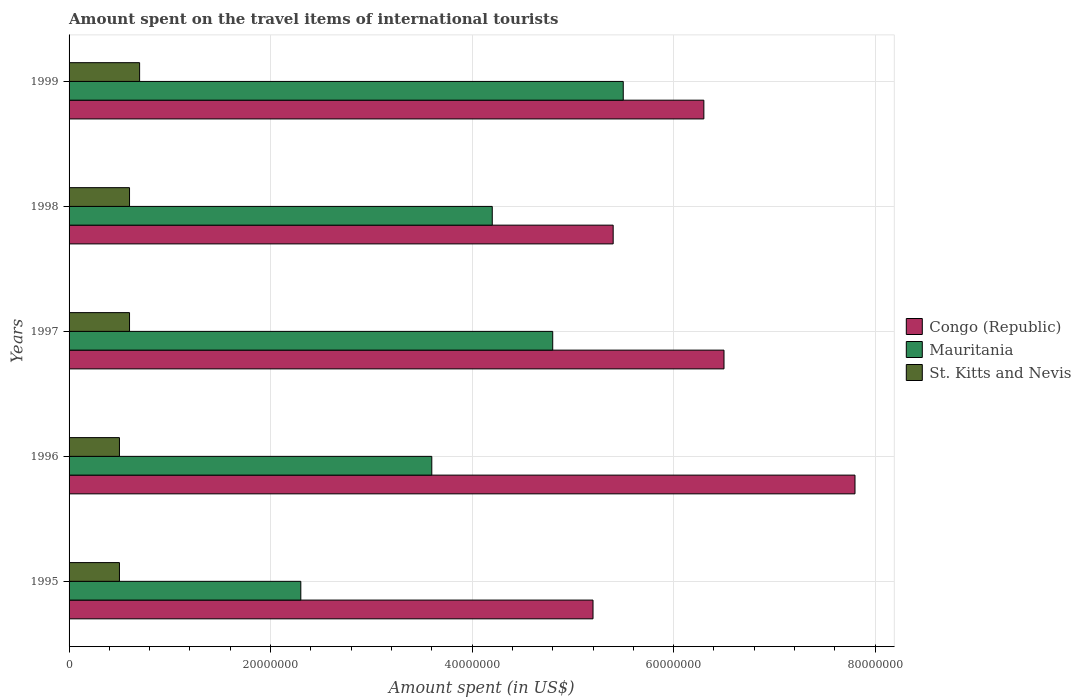How many different coloured bars are there?
Offer a terse response. 3. Are the number of bars on each tick of the Y-axis equal?
Your response must be concise. Yes. How many bars are there on the 4th tick from the bottom?
Provide a succinct answer. 3. In how many cases, is the number of bars for a given year not equal to the number of legend labels?
Make the answer very short. 0. What is the amount spent on the travel items of international tourists in St. Kitts and Nevis in 1997?
Provide a short and direct response. 6.00e+06. Across all years, what is the maximum amount spent on the travel items of international tourists in Congo (Republic)?
Your response must be concise. 7.80e+07. Across all years, what is the minimum amount spent on the travel items of international tourists in Mauritania?
Offer a very short reply. 2.30e+07. What is the total amount spent on the travel items of international tourists in Mauritania in the graph?
Your answer should be compact. 2.04e+08. What is the difference between the amount spent on the travel items of international tourists in St. Kitts and Nevis in 1998 and that in 1999?
Make the answer very short. -1.00e+06. What is the difference between the amount spent on the travel items of international tourists in Mauritania in 1996 and the amount spent on the travel items of international tourists in Congo (Republic) in 1997?
Offer a terse response. -2.90e+07. What is the average amount spent on the travel items of international tourists in Congo (Republic) per year?
Provide a short and direct response. 6.24e+07. In how many years, is the amount spent on the travel items of international tourists in Congo (Republic) greater than 64000000 US$?
Offer a terse response. 2. What is the ratio of the amount spent on the travel items of international tourists in Mauritania in 1997 to that in 1998?
Offer a terse response. 1.14. Is the amount spent on the travel items of international tourists in St. Kitts and Nevis in 1995 less than that in 1996?
Your response must be concise. No. Is the difference between the amount spent on the travel items of international tourists in Congo (Republic) in 1995 and 1998 greater than the difference between the amount spent on the travel items of international tourists in Mauritania in 1995 and 1998?
Your answer should be compact. Yes. What is the difference between the highest and the second highest amount spent on the travel items of international tourists in Mauritania?
Keep it short and to the point. 7.00e+06. What is the difference between the highest and the lowest amount spent on the travel items of international tourists in Mauritania?
Your answer should be very brief. 3.20e+07. In how many years, is the amount spent on the travel items of international tourists in St. Kitts and Nevis greater than the average amount spent on the travel items of international tourists in St. Kitts and Nevis taken over all years?
Make the answer very short. 3. What does the 2nd bar from the top in 1995 represents?
Provide a succinct answer. Mauritania. What does the 2nd bar from the bottom in 1996 represents?
Offer a terse response. Mauritania. How many bars are there?
Provide a succinct answer. 15. How many years are there in the graph?
Your answer should be compact. 5. Are the values on the major ticks of X-axis written in scientific E-notation?
Your answer should be very brief. No. Does the graph contain any zero values?
Provide a succinct answer. No. Where does the legend appear in the graph?
Provide a short and direct response. Center right. How many legend labels are there?
Keep it short and to the point. 3. How are the legend labels stacked?
Offer a very short reply. Vertical. What is the title of the graph?
Offer a terse response. Amount spent on the travel items of international tourists. What is the label or title of the X-axis?
Ensure brevity in your answer.  Amount spent (in US$). What is the label or title of the Y-axis?
Your answer should be compact. Years. What is the Amount spent (in US$) in Congo (Republic) in 1995?
Your answer should be very brief. 5.20e+07. What is the Amount spent (in US$) in Mauritania in 1995?
Give a very brief answer. 2.30e+07. What is the Amount spent (in US$) in St. Kitts and Nevis in 1995?
Your response must be concise. 5.00e+06. What is the Amount spent (in US$) in Congo (Republic) in 1996?
Provide a short and direct response. 7.80e+07. What is the Amount spent (in US$) in Mauritania in 1996?
Your response must be concise. 3.60e+07. What is the Amount spent (in US$) in St. Kitts and Nevis in 1996?
Ensure brevity in your answer.  5.00e+06. What is the Amount spent (in US$) of Congo (Republic) in 1997?
Your answer should be very brief. 6.50e+07. What is the Amount spent (in US$) of Mauritania in 1997?
Ensure brevity in your answer.  4.80e+07. What is the Amount spent (in US$) in Congo (Republic) in 1998?
Make the answer very short. 5.40e+07. What is the Amount spent (in US$) of Mauritania in 1998?
Give a very brief answer. 4.20e+07. What is the Amount spent (in US$) of Congo (Republic) in 1999?
Your answer should be very brief. 6.30e+07. What is the Amount spent (in US$) in Mauritania in 1999?
Your answer should be compact. 5.50e+07. What is the Amount spent (in US$) in St. Kitts and Nevis in 1999?
Provide a short and direct response. 7.00e+06. Across all years, what is the maximum Amount spent (in US$) in Congo (Republic)?
Offer a terse response. 7.80e+07. Across all years, what is the maximum Amount spent (in US$) in Mauritania?
Offer a very short reply. 5.50e+07. Across all years, what is the minimum Amount spent (in US$) in Congo (Republic)?
Provide a succinct answer. 5.20e+07. Across all years, what is the minimum Amount spent (in US$) of Mauritania?
Your response must be concise. 2.30e+07. Across all years, what is the minimum Amount spent (in US$) of St. Kitts and Nevis?
Give a very brief answer. 5.00e+06. What is the total Amount spent (in US$) of Congo (Republic) in the graph?
Provide a short and direct response. 3.12e+08. What is the total Amount spent (in US$) of Mauritania in the graph?
Keep it short and to the point. 2.04e+08. What is the total Amount spent (in US$) in St. Kitts and Nevis in the graph?
Ensure brevity in your answer.  2.90e+07. What is the difference between the Amount spent (in US$) in Congo (Republic) in 1995 and that in 1996?
Ensure brevity in your answer.  -2.60e+07. What is the difference between the Amount spent (in US$) in Mauritania in 1995 and that in 1996?
Give a very brief answer. -1.30e+07. What is the difference between the Amount spent (in US$) in Congo (Republic) in 1995 and that in 1997?
Your answer should be very brief. -1.30e+07. What is the difference between the Amount spent (in US$) of Mauritania in 1995 and that in 1997?
Your answer should be compact. -2.50e+07. What is the difference between the Amount spent (in US$) of Mauritania in 1995 and that in 1998?
Your answer should be very brief. -1.90e+07. What is the difference between the Amount spent (in US$) in Congo (Republic) in 1995 and that in 1999?
Give a very brief answer. -1.10e+07. What is the difference between the Amount spent (in US$) of Mauritania in 1995 and that in 1999?
Provide a succinct answer. -3.20e+07. What is the difference between the Amount spent (in US$) in St. Kitts and Nevis in 1995 and that in 1999?
Ensure brevity in your answer.  -2.00e+06. What is the difference between the Amount spent (in US$) of Congo (Republic) in 1996 and that in 1997?
Make the answer very short. 1.30e+07. What is the difference between the Amount spent (in US$) in Mauritania in 1996 and that in 1997?
Your answer should be very brief. -1.20e+07. What is the difference between the Amount spent (in US$) in St. Kitts and Nevis in 1996 and that in 1997?
Make the answer very short. -1.00e+06. What is the difference between the Amount spent (in US$) in Congo (Republic) in 1996 and that in 1998?
Give a very brief answer. 2.40e+07. What is the difference between the Amount spent (in US$) in Mauritania in 1996 and that in 1998?
Your answer should be very brief. -6.00e+06. What is the difference between the Amount spent (in US$) of St. Kitts and Nevis in 1996 and that in 1998?
Your answer should be very brief. -1.00e+06. What is the difference between the Amount spent (in US$) in Congo (Republic) in 1996 and that in 1999?
Your answer should be very brief. 1.50e+07. What is the difference between the Amount spent (in US$) of Mauritania in 1996 and that in 1999?
Your answer should be compact. -1.90e+07. What is the difference between the Amount spent (in US$) of Congo (Republic) in 1997 and that in 1998?
Your answer should be very brief. 1.10e+07. What is the difference between the Amount spent (in US$) in Mauritania in 1997 and that in 1999?
Your answer should be very brief. -7.00e+06. What is the difference between the Amount spent (in US$) in St. Kitts and Nevis in 1997 and that in 1999?
Your answer should be very brief. -1.00e+06. What is the difference between the Amount spent (in US$) in Congo (Republic) in 1998 and that in 1999?
Give a very brief answer. -9.00e+06. What is the difference between the Amount spent (in US$) in Mauritania in 1998 and that in 1999?
Ensure brevity in your answer.  -1.30e+07. What is the difference between the Amount spent (in US$) in Congo (Republic) in 1995 and the Amount spent (in US$) in Mauritania in 1996?
Your answer should be compact. 1.60e+07. What is the difference between the Amount spent (in US$) of Congo (Republic) in 1995 and the Amount spent (in US$) of St. Kitts and Nevis in 1996?
Provide a short and direct response. 4.70e+07. What is the difference between the Amount spent (in US$) in Mauritania in 1995 and the Amount spent (in US$) in St. Kitts and Nevis in 1996?
Your answer should be compact. 1.80e+07. What is the difference between the Amount spent (in US$) of Congo (Republic) in 1995 and the Amount spent (in US$) of St. Kitts and Nevis in 1997?
Give a very brief answer. 4.60e+07. What is the difference between the Amount spent (in US$) of Mauritania in 1995 and the Amount spent (in US$) of St. Kitts and Nevis in 1997?
Provide a succinct answer. 1.70e+07. What is the difference between the Amount spent (in US$) of Congo (Republic) in 1995 and the Amount spent (in US$) of St. Kitts and Nevis in 1998?
Make the answer very short. 4.60e+07. What is the difference between the Amount spent (in US$) in Mauritania in 1995 and the Amount spent (in US$) in St. Kitts and Nevis in 1998?
Offer a terse response. 1.70e+07. What is the difference between the Amount spent (in US$) in Congo (Republic) in 1995 and the Amount spent (in US$) in St. Kitts and Nevis in 1999?
Your response must be concise. 4.50e+07. What is the difference between the Amount spent (in US$) in Mauritania in 1995 and the Amount spent (in US$) in St. Kitts and Nevis in 1999?
Ensure brevity in your answer.  1.60e+07. What is the difference between the Amount spent (in US$) in Congo (Republic) in 1996 and the Amount spent (in US$) in Mauritania in 1997?
Ensure brevity in your answer.  3.00e+07. What is the difference between the Amount spent (in US$) of Congo (Republic) in 1996 and the Amount spent (in US$) of St. Kitts and Nevis in 1997?
Keep it short and to the point. 7.20e+07. What is the difference between the Amount spent (in US$) of Mauritania in 1996 and the Amount spent (in US$) of St. Kitts and Nevis in 1997?
Offer a very short reply. 3.00e+07. What is the difference between the Amount spent (in US$) in Congo (Republic) in 1996 and the Amount spent (in US$) in Mauritania in 1998?
Ensure brevity in your answer.  3.60e+07. What is the difference between the Amount spent (in US$) of Congo (Republic) in 1996 and the Amount spent (in US$) of St. Kitts and Nevis in 1998?
Make the answer very short. 7.20e+07. What is the difference between the Amount spent (in US$) of Mauritania in 1996 and the Amount spent (in US$) of St. Kitts and Nevis in 1998?
Keep it short and to the point. 3.00e+07. What is the difference between the Amount spent (in US$) in Congo (Republic) in 1996 and the Amount spent (in US$) in Mauritania in 1999?
Provide a succinct answer. 2.30e+07. What is the difference between the Amount spent (in US$) in Congo (Republic) in 1996 and the Amount spent (in US$) in St. Kitts and Nevis in 1999?
Keep it short and to the point. 7.10e+07. What is the difference between the Amount spent (in US$) of Mauritania in 1996 and the Amount spent (in US$) of St. Kitts and Nevis in 1999?
Ensure brevity in your answer.  2.90e+07. What is the difference between the Amount spent (in US$) of Congo (Republic) in 1997 and the Amount spent (in US$) of Mauritania in 1998?
Give a very brief answer. 2.30e+07. What is the difference between the Amount spent (in US$) of Congo (Republic) in 1997 and the Amount spent (in US$) of St. Kitts and Nevis in 1998?
Ensure brevity in your answer.  5.90e+07. What is the difference between the Amount spent (in US$) in Mauritania in 1997 and the Amount spent (in US$) in St. Kitts and Nevis in 1998?
Offer a terse response. 4.20e+07. What is the difference between the Amount spent (in US$) in Congo (Republic) in 1997 and the Amount spent (in US$) in Mauritania in 1999?
Your answer should be compact. 1.00e+07. What is the difference between the Amount spent (in US$) in Congo (Republic) in 1997 and the Amount spent (in US$) in St. Kitts and Nevis in 1999?
Provide a succinct answer. 5.80e+07. What is the difference between the Amount spent (in US$) in Mauritania in 1997 and the Amount spent (in US$) in St. Kitts and Nevis in 1999?
Give a very brief answer. 4.10e+07. What is the difference between the Amount spent (in US$) of Congo (Republic) in 1998 and the Amount spent (in US$) of St. Kitts and Nevis in 1999?
Offer a very short reply. 4.70e+07. What is the difference between the Amount spent (in US$) in Mauritania in 1998 and the Amount spent (in US$) in St. Kitts and Nevis in 1999?
Ensure brevity in your answer.  3.50e+07. What is the average Amount spent (in US$) in Congo (Republic) per year?
Keep it short and to the point. 6.24e+07. What is the average Amount spent (in US$) of Mauritania per year?
Give a very brief answer. 4.08e+07. What is the average Amount spent (in US$) in St. Kitts and Nevis per year?
Offer a terse response. 5.80e+06. In the year 1995, what is the difference between the Amount spent (in US$) in Congo (Republic) and Amount spent (in US$) in Mauritania?
Provide a short and direct response. 2.90e+07. In the year 1995, what is the difference between the Amount spent (in US$) in Congo (Republic) and Amount spent (in US$) in St. Kitts and Nevis?
Your answer should be very brief. 4.70e+07. In the year 1995, what is the difference between the Amount spent (in US$) of Mauritania and Amount spent (in US$) of St. Kitts and Nevis?
Offer a terse response. 1.80e+07. In the year 1996, what is the difference between the Amount spent (in US$) of Congo (Republic) and Amount spent (in US$) of Mauritania?
Offer a very short reply. 4.20e+07. In the year 1996, what is the difference between the Amount spent (in US$) in Congo (Republic) and Amount spent (in US$) in St. Kitts and Nevis?
Your response must be concise. 7.30e+07. In the year 1996, what is the difference between the Amount spent (in US$) in Mauritania and Amount spent (in US$) in St. Kitts and Nevis?
Make the answer very short. 3.10e+07. In the year 1997, what is the difference between the Amount spent (in US$) in Congo (Republic) and Amount spent (in US$) in Mauritania?
Give a very brief answer. 1.70e+07. In the year 1997, what is the difference between the Amount spent (in US$) of Congo (Republic) and Amount spent (in US$) of St. Kitts and Nevis?
Your answer should be compact. 5.90e+07. In the year 1997, what is the difference between the Amount spent (in US$) in Mauritania and Amount spent (in US$) in St. Kitts and Nevis?
Your answer should be very brief. 4.20e+07. In the year 1998, what is the difference between the Amount spent (in US$) in Congo (Republic) and Amount spent (in US$) in St. Kitts and Nevis?
Provide a succinct answer. 4.80e+07. In the year 1998, what is the difference between the Amount spent (in US$) in Mauritania and Amount spent (in US$) in St. Kitts and Nevis?
Your answer should be very brief. 3.60e+07. In the year 1999, what is the difference between the Amount spent (in US$) of Congo (Republic) and Amount spent (in US$) of Mauritania?
Provide a succinct answer. 8.00e+06. In the year 1999, what is the difference between the Amount spent (in US$) in Congo (Republic) and Amount spent (in US$) in St. Kitts and Nevis?
Offer a very short reply. 5.60e+07. In the year 1999, what is the difference between the Amount spent (in US$) in Mauritania and Amount spent (in US$) in St. Kitts and Nevis?
Your answer should be compact. 4.80e+07. What is the ratio of the Amount spent (in US$) in Congo (Republic) in 1995 to that in 1996?
Provide a succinct answer. 0.67. What is the ratio of the Amount spent (in US$) in Mauritania in 1995 to that in 1996?
Your response must be concise. 0.64. What is the ratio of the Amount spent (in US$) in St. Kitts and Nevis in 1995 to that in 1996?
Provide a short and direct response. 1. What is the ratio of the Amount spent (in US$) in Mauritania in 1995 to that in 1997?
Make the answer very short. 0.48. What is the ratio of the Amount spent (in US$) of Congo (Republic) in 1995 to that in 1998?
Ensure brevity in your answer.  0.96. What is the ratio of the Amount spent (in US$) in Mauritania in 1995 to that in 1998?
Give a very brief answer. 0.55. What is the ratio of the Amount spent (in US$) of Congo (Republic) in 1995 to that in 1999?
Offer a very short reply. 0.83. What is the ratio of the Amount spent (in US$) of Mauritania in 1995 to that in 1999?
Provide a short and direct response. 0.42. What is the ratio of the Amount spent (in US$) of St. Kitts and Nevis in 1996 to that in 1997?
Provide a succinct answer. 0.83. What is the ratio of the Amount spent (in US$) of Congo (Republic) in 1996 to that in 1998?
Your answer should be compact. 1.44. What is the ratio of the Amount spent (in US$) of Mauritania in 1996 to that in 1998?
Your answer should be very brief. 0.86. What is the ratio of the Amount spent (in US$) in Congo (Republic) in 1996 to that in 1999?
Your response must be concise. 1.24. What is the ratio of the Amount spent (in US$) in Mauritania in 1996 to that in 1999?
Offer a terse response. 0.65. What is the ratio of the Amount spent (in US$) in Congo (Republic) in 1997 to that in 1998?
Provide a short and direct response. 1.2. What is the ratio of the Amount spent (in US$) of St. Kitts and Nevis in 1997 to that in 1998?
Offer a very short reply. 1. What is the ratio of the Amount spent (in US$) of Congo (Republic) in 1997 to that in 1999?
Give a very brief answer. 1.03. What is the ratio of the Amount spent (in US$) in Mauritania in 1997 to that in 1999?
Offer a terse response. 0.87. What is the ratio of the Amount spent (in US$) of Congo (Republic) in 1998 to that in 1999?
Your answer should be compact. 0.86. What is the ratio of the Amount spent (in US$) in Mauritania in 1998 to that in 1999?
Offer a very short reply. 0.76. What is the ratio of the Amount spent (in US$) of St. Kitts and Nevis in 1998 to that in 1999?
Offer a terse response. 0.86. What is the difference between the highest and the second highest Amount spent (in US$) of Congo (Republic)?
Offer a terse response. 1.30e+07. What is the difference between the highest and the second highest Amount spent (in US$) in Mauritania?
Your response must be concise. 7.00e+06. What is the difference between the highest and the lowest Amount spent (in US$) of Congo (Republic)?
Provide a short and direct response. 2.60e+07. What is the difference between the highest and the lowest Amount spent (in US$) of Mauritania?
Your response must be concise. 3.20e+07. What is the difference between the highest and the lowest Amount spent (in US$) in St. Kitts and Nevis?
Make the answer very short. 2.00e+06. 